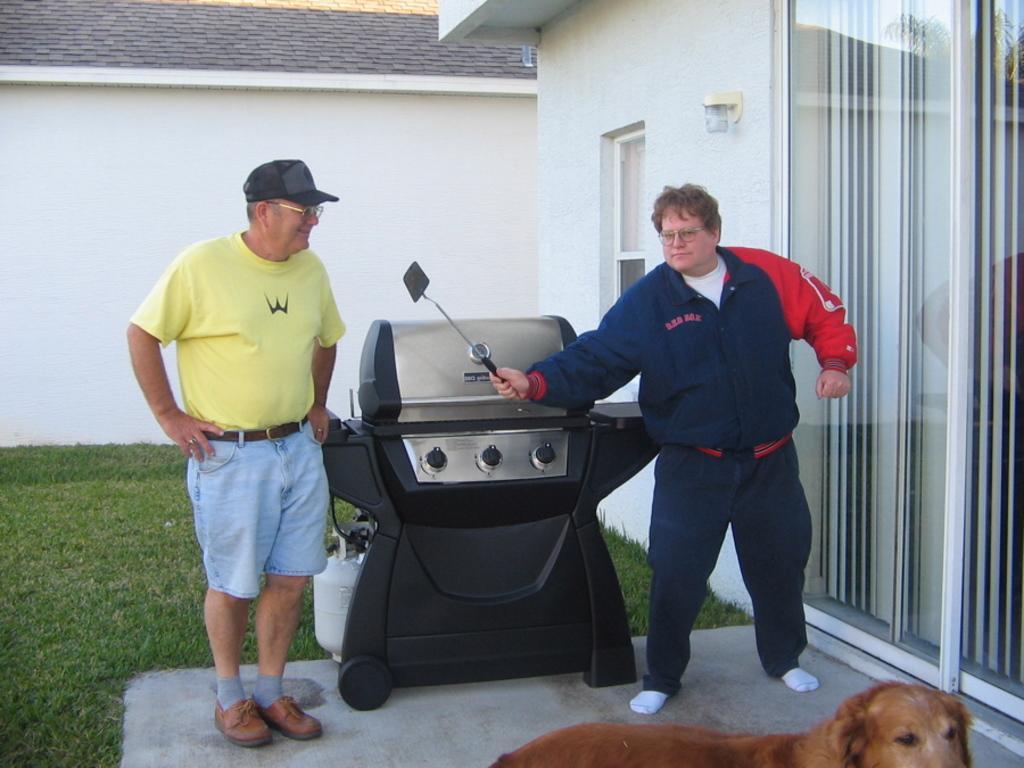How would you summarize this image in a sentence or two? In this image, we can see a few people. We can also see a black colored object. We can see the ground. We can see some grass. We can see a dog. We can see some glass doors. We can see the wall with the window and an object. 